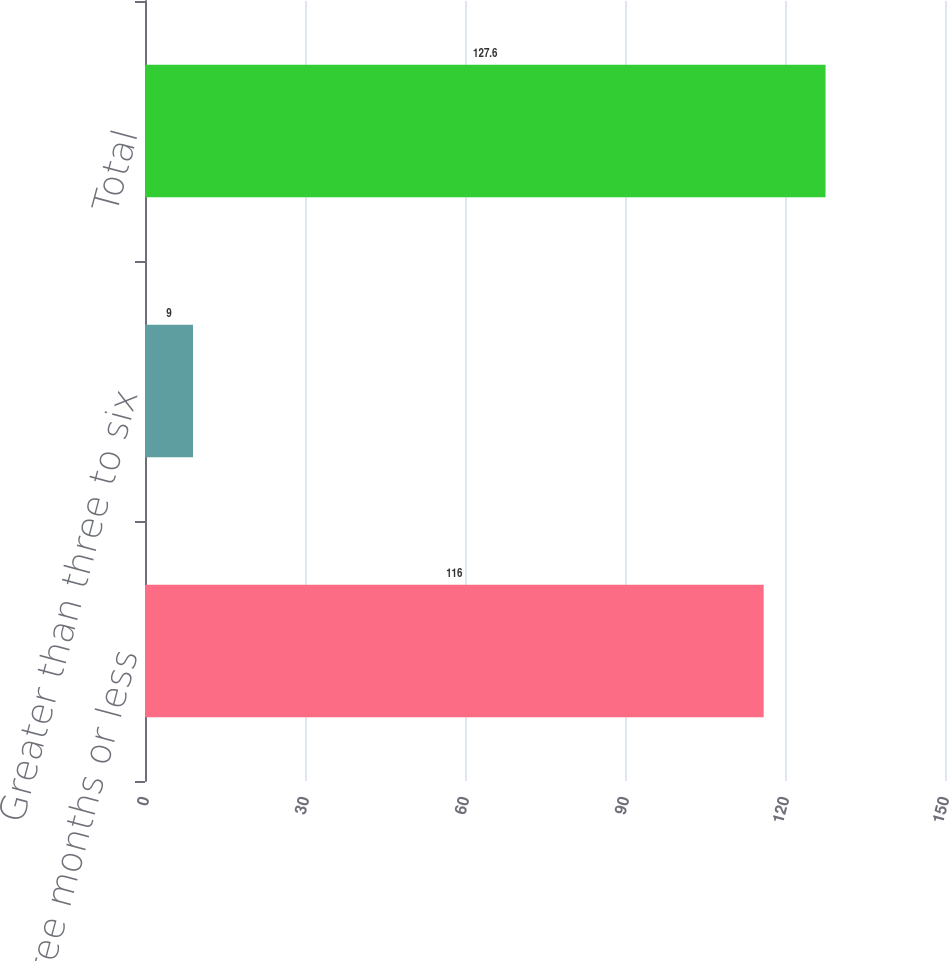Convert chart. <chart><loc_0><loc_0><loc_500><loc_500><bar_chart><fcel>Three months or less<fcel>Greater than three to six<fcel>Total<nl><fcel>116<fcel>9<fcel>127.6<nl></chart> 